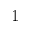<formula> <loc_0><loc_0><loc_500><loc_500>1</formula> 